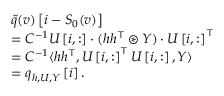<formula> <loc_0><loc_0><loc_500><loc_500>\begin{array} { r l } & { \tilde { q } ( v ) \left [ i - S _ { 0 } ( v ) \right ] } \\ & { = C ^ { - 1 } U \left [ i , \colon \right ] \cdot ( h h ^ { \top } \circledast Y ) \cdot U \left [ i , \colon \right ] ^ { \top } } \\ & { = C ^ { - 1 } \langle h h ^ { \top } , U \left [ i , \colon \right ] ^ { \top } U \left [ i , \colon \right ] , Y \rangle } \\ & { = q _ { h , U , Y } \left [ i \right ] . } \end{array}</formula> 